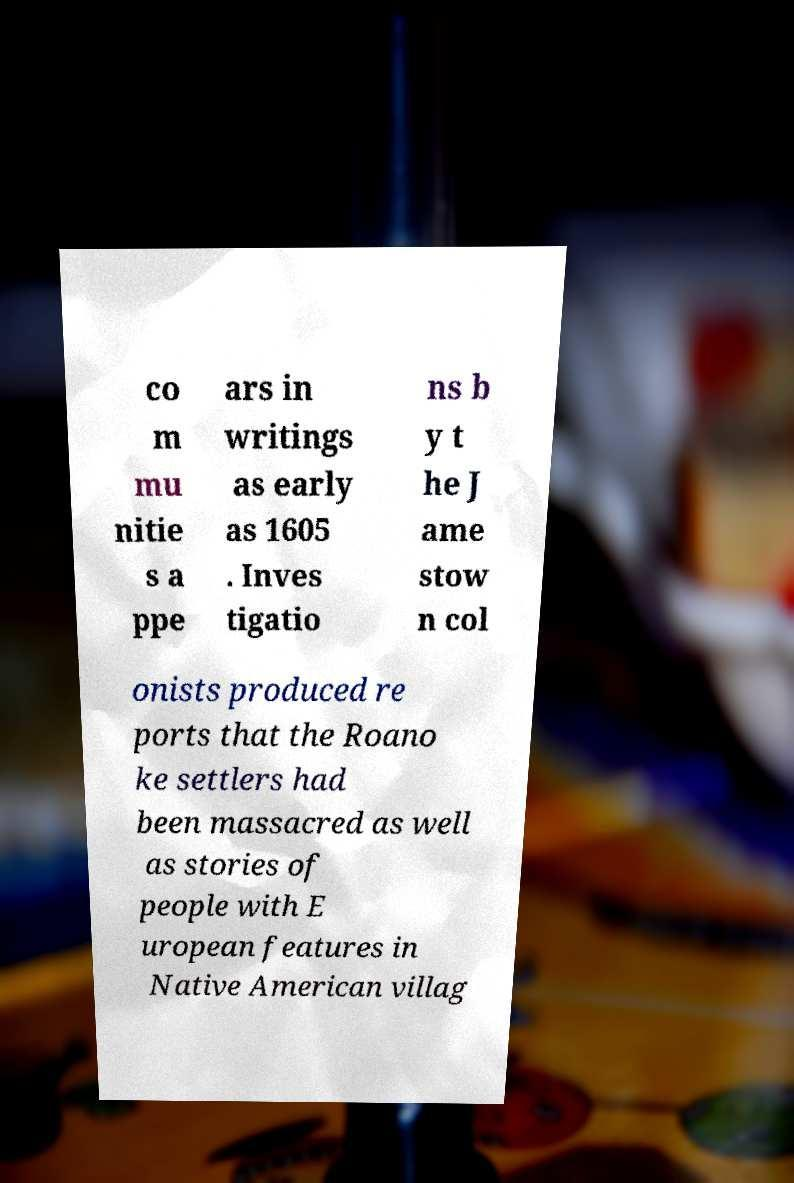Could you assist in decoding the text presented in this image and type it out clearly? co m mu nitie s a ppe ars in writings as early as 1605 . Inves tigatio ns b y t he J ame stow n col onists produced re ports that the Roano ke settlers had been massacred as well as stories of people with E uropean features in Native American villag 